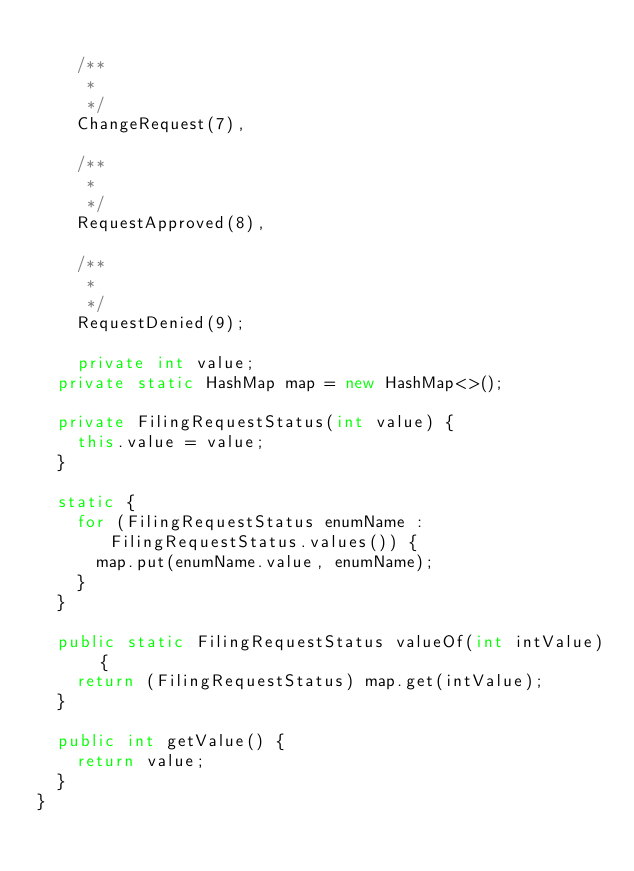Convert code to text. <code><loc_0><loc_0><loc_500><loc_500><_Java_>
    /** 
     * 
     */
    ChangeRequest(7),

    /** 
     * 
     */
    RequestApproved(8),

    /** 
     * 
     */
    RequestDenied(9);

    private int value;
	private static HashMap map = new HashMap<>();
	
	private FilingRequestStatus(int value) {
		this.value = value;
	}
	
	static {
		for (FilingRequestStatus enumName : FilingRequestStatus.values()) {
			map.put(enumName.value, enumName);
		}
	}
	
	public static FilingRequestStatus valueOf(int intValue) {
		return (FilingRequestStatus) map.get(intValue);
	}
	
	public int getValue() {
		return value;
	}
}
</code> 